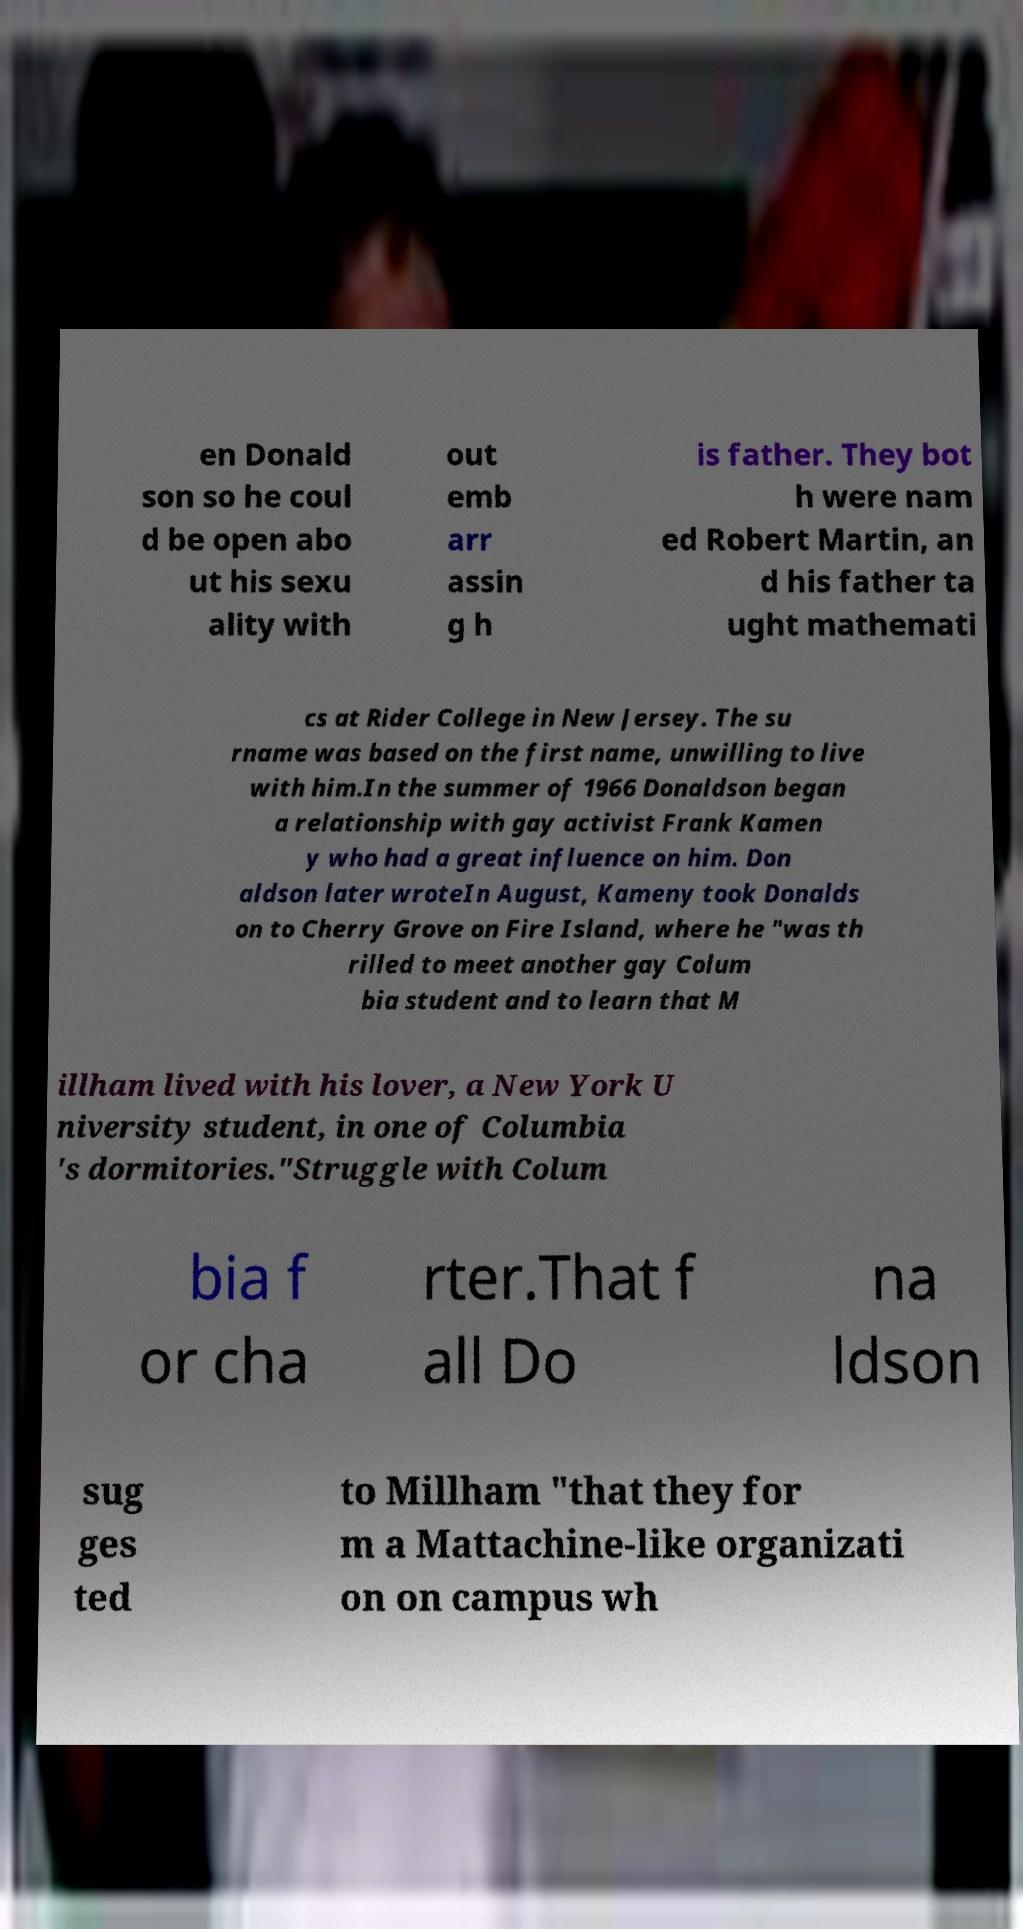Can you read and provide the text displayed in the image?This photo seems to have some interesting text. Can you extract and type it out for me? en Donald son so he coul d be open abo ut his sexu ality with out emb arr assin g h is father. They bot h were nam ed Robert Martin, an d his father ta ught mathemati cs at Rider College in New Jersey. The su rname was based on the first name, unwilling to live with him.In the summer of 1966 Donaldson began a relationship with gay activist Frank Kamen y who had a great influence on him. Don aldson later wroteIn August, Kameny took Donalds on to Cherry Grove on Fire Island, where he "was th rilled to meet another gay Colum bia student and to learn that M illham lived with his lover, a New York U niversity student, in one of Columbia 's dormitories."Struggle with Colum bia f or cha rter.That f all Do na ldson sug ges ted to Millham "that they for m a Mattachine-like organizati on on campus wh 